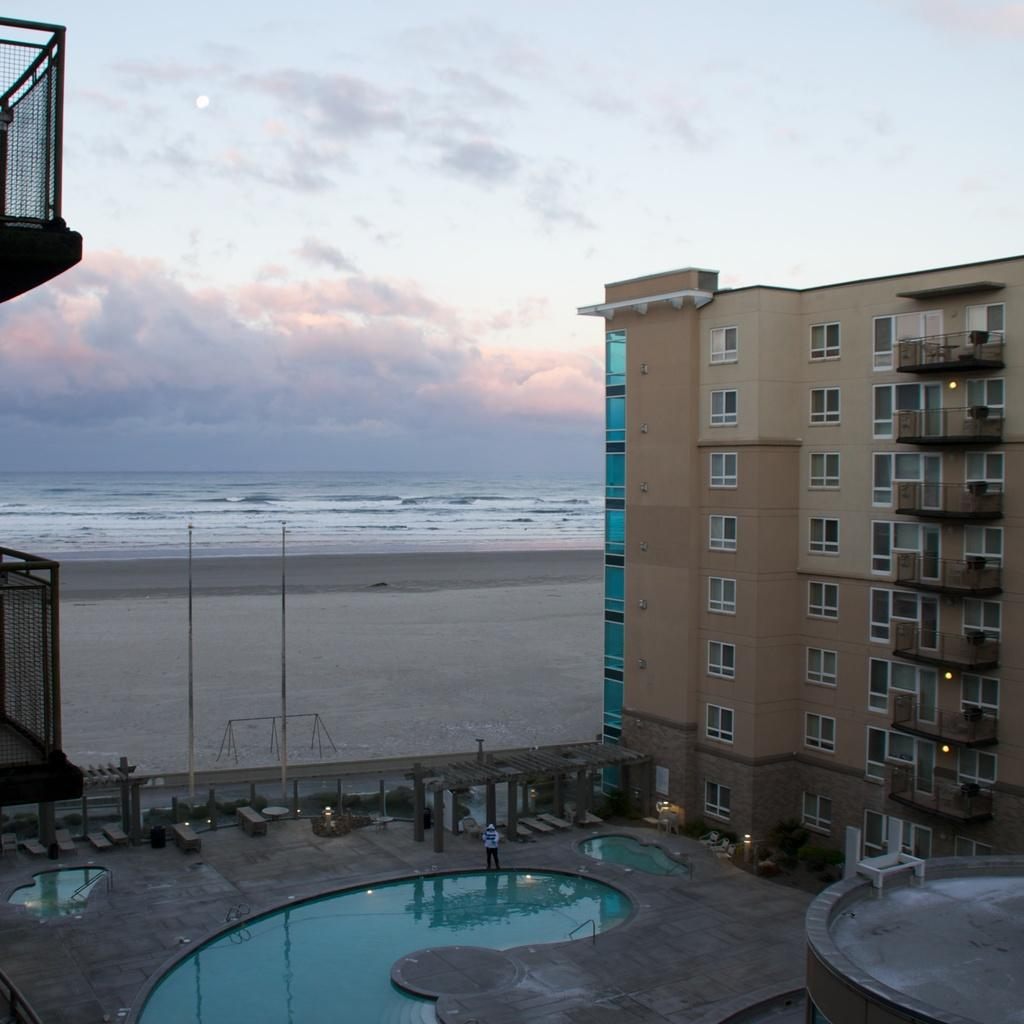What type of structure is present in the image? There is a building in the image. What is located in front of the building? There is a swimming pool in front of the building. Can you describe the person in the image? There is a person in the image, but their appearance or actions are not specified. What type of seating is available in the image? There is a bench in the image. What type of barrier is present in the image? There is a fence in the image. What is the purpose of the pole in the image? The purpose of the pole in the image is not specified. What can be seen in the image besides the building and swimming pool? There is water visible in the image. What part of the natural environment is visible in the image? The sky is visible in the image. Where is the home located in the image? The provided facts do not mention a home in the image. The image features a building, but it is not specified as a home. 